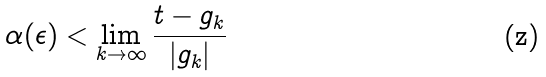<formula> <loc_0><loc_0><loc_500><loc_500>\alpha ( \epsilon ) < \lim _ { k \rightarrow \infty } \frac { t - g _ { k } } { | g _ { k } | }</formula> 